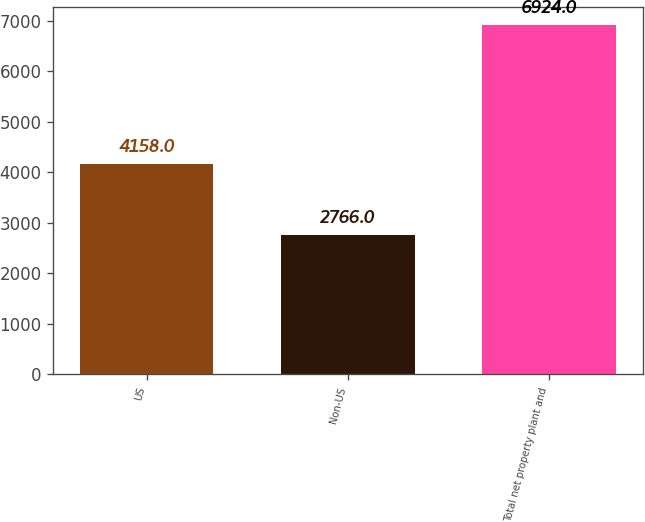Convert chart to OTSL. <chart><loc_0><loc_0><loc_500><loc_500><bar_chart><fcel>US<fcel>Non-US<fcel>Total net property plant and<nl><fcel>4158<fcel>2766<fcel>6924<nl></chart> 